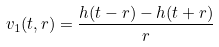<formula> <loc_0><loc_0><loc_500><loc_500>v _ { 1 } ( t , r ) = \frac { h ( t - r ) - h ( t + r ) } { r }</formula> 